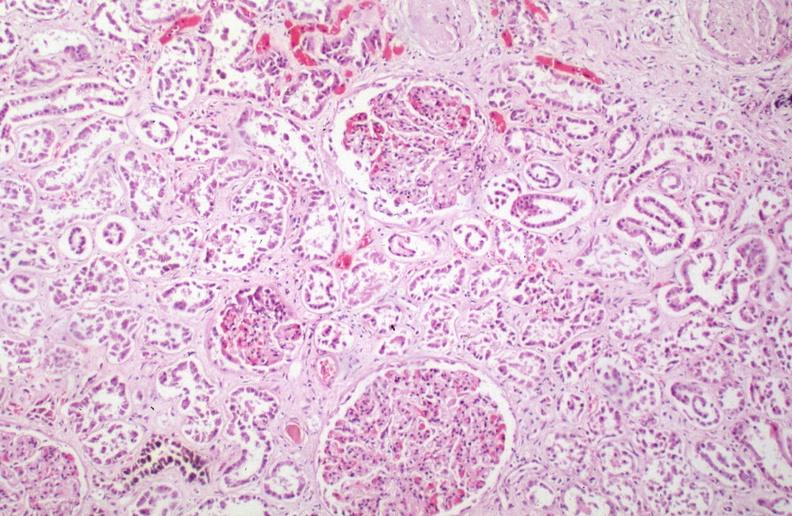how is hemosiderosis caused by blood transfusions?
Answer the question using a single word or phrase. Numerous 